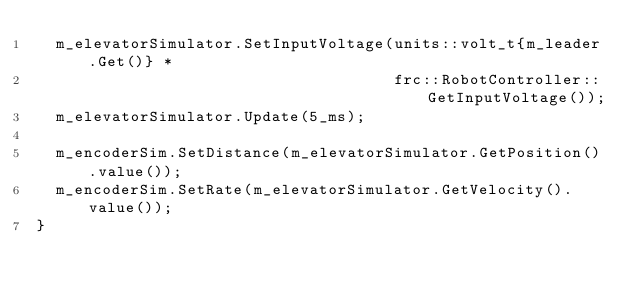<code> <loc_0><loc_0><loc_500><loc_500><_C++_>  m_elevatorSimulator.SetInputVoltage(units::volt_t{m_leader.Get()} *
                                      frc::RobotController::GetInputVoltage());
  m_elevatorSimulator.Update(5_ms);

  m_encoderSim.SetDistance(m_elevatorSimulator.GetPosition().value());
  m_encoderSim.SetRate(m_elevatorSimulator.GetVelocity().value());
}
</code> 